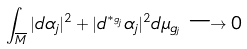Convert formula to latex. <formula><loc_0><loc_0><loc_500><loc_500>\int _ { \overline { M } } | d \alpha _ { j } | ^ { 2 } + | d ^ { * _ { g _ { j } } } \alpha _ { j } | ^ { 2 } d \mu _ { g _ { j } } \longrightarrow 0</formula> 